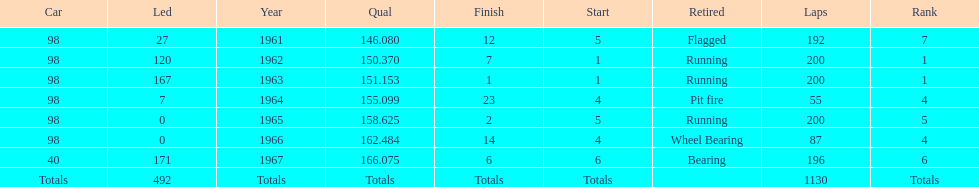How many total laps have been driven in the indy 500? 1130. 